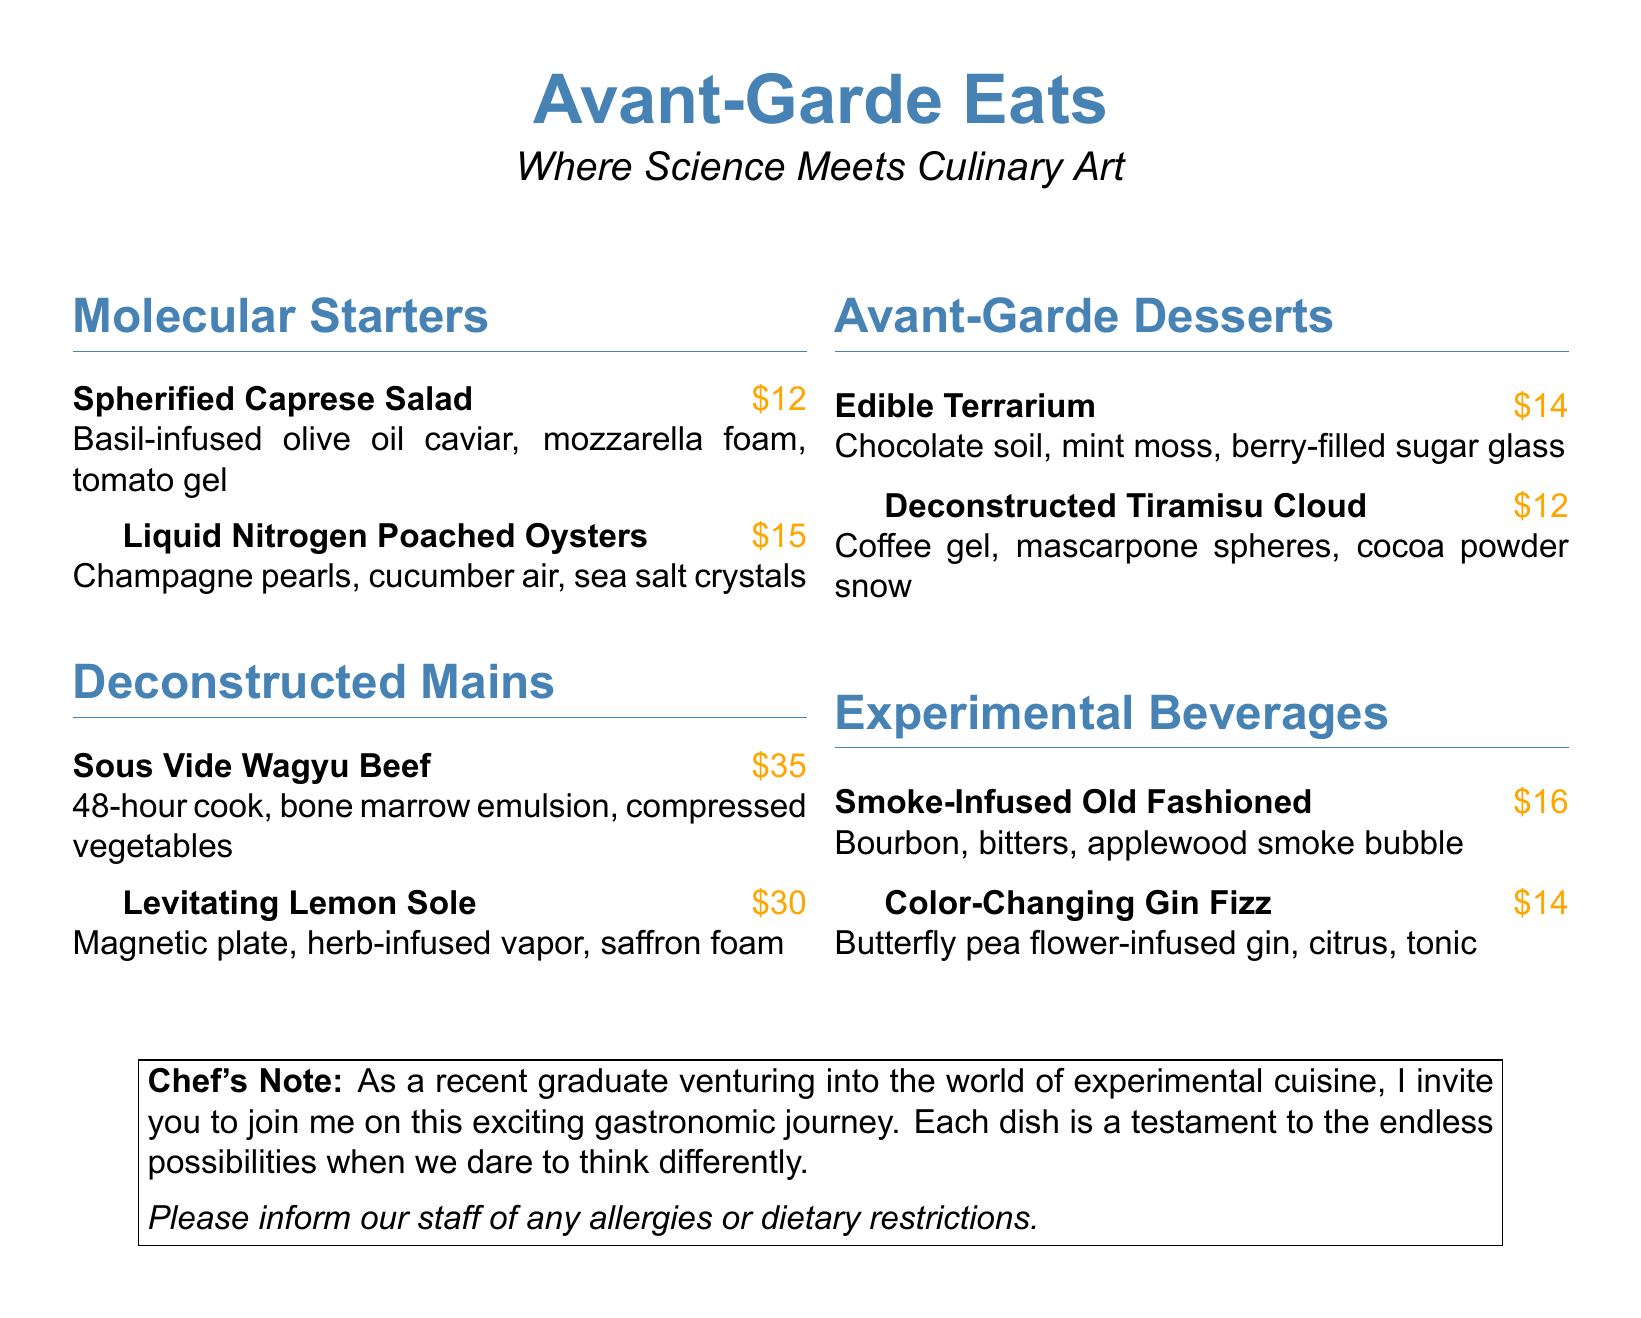What is the name of the pop-up dinner series? The title of the pop-up dinner series is prominently displayed at the top of the document.
Answer: Avant-Garde Eats What is the price of the Spherified Caprese Salad? The menu lists the price next to each dish.
Answer: $12 What cooking technique is used for the Sous Vide Wagyu Beef? This information can be found in the description of the dish.
Answer: Sous Vide How many dishes are classified as Molecular Starters? By counting the items listed under the Molecular Starters section.
Answer: 2 What is the main ingredient in the Liquid Nitrogen Poached Oysters? The description of the dish specifies the key elements it contains.
Answer: Oysters What beverage is described as color-changing? The document specifically highlights this characteristic in the drink's name.
Answer: Color-Changing Gin Fizz Which dessert features a chocolate soil? The menu explicitly mentions this detail in the dessert description.
Answer: Edible Terrarium What does the chef invite guests to join? This is stated in the Chef's Note at the end of the document.
Answer: Exciting gastronomic journey What dietary considerations should guests inform the staff about? The note at the bottom advises on specific considerations regarding dining.
Answer: Allergies or dietary restrictions 